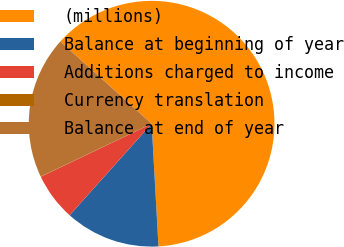<chart> <loc_0><loc_0><loc_500><loc_500><pie_chart><fcel>(millions)<fcel>Balance at beginning of year<fcel>Additions charged to income<fcel>Currency translation<fcel>Balance at end of year<nl><fcel>62.43%<fcel>12.51%<fcel>6.27%<fcel>0.03%<fcel>18.75%<nl></chart> 